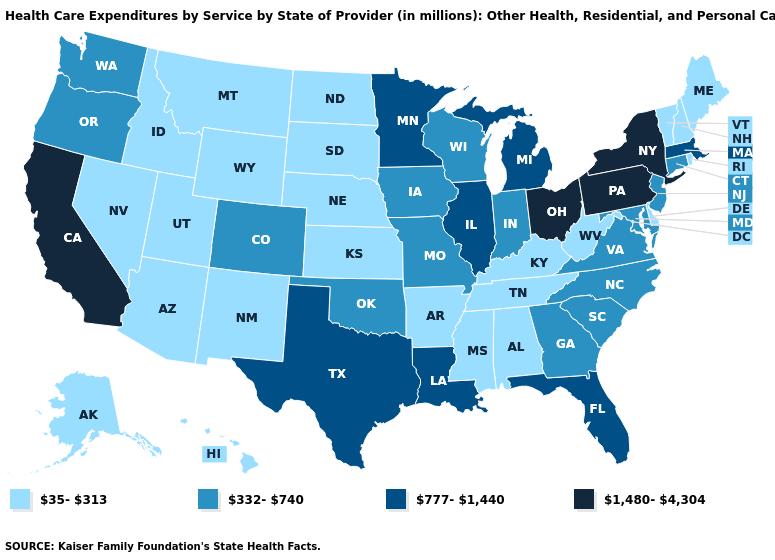What is the highest value in states that border South Carolina?
Be succinct. 332-740. Among the states that border Mississippi , which have the lowest value?
Concise answer only. Alabama, Arkansas, Tennessee. Does Alabama have the lowest value in the USA?
Quick response, please. Yes. Name the states that have a value in the range 332-740?
Keep it brief. Colorado, Connecticut, Georgia, Indiana, Iowa, Maryland, Missouri, New Jersey, North Carolina, Oklahoma, Oregon, South Carolina, Virginia, Washington, Wisconsin. Which states hav the highest value in the MidWest?
Quick response, please. Ohio. Name the states that have a value in the range 777-1,440?
Give a very brief answer. Florida, Illinois, Louisiana, Massachusetts, Michigan, Minnesota, Texas. Is the legend a continuous bar?
Be succinct. No. Which states hav the highest value in the Northeast?
Short answer required. New York, Pennsylvania. Among the states that border Tennessee , which have the highest value?
Give a very brief answer. Georgia, Missouri, North Carolina, Virginia. Among the states that border Kentucky , which have the lowest value?
Answer briefly. Tennessee, West Virginia. What is the value of Texas?
Give a very brief answer. 777-1,440. Does Idaho have a lower value than Alaska?
Short answer required. No. What is the value of Illinois?
Answer briefly. 777-1,440. Name the states that have a value in the range 332-740?
Short answer required. Colorado, Connecticut, Georgia, Indiana, Iowa, Maryland, Missouri, New Jersey, North Carolina, Oklahoma, Oregon, South Carolina, Virginia, Washington, Wisconsin. How many symbols are there in the legend?
Quick response, please. 4. 